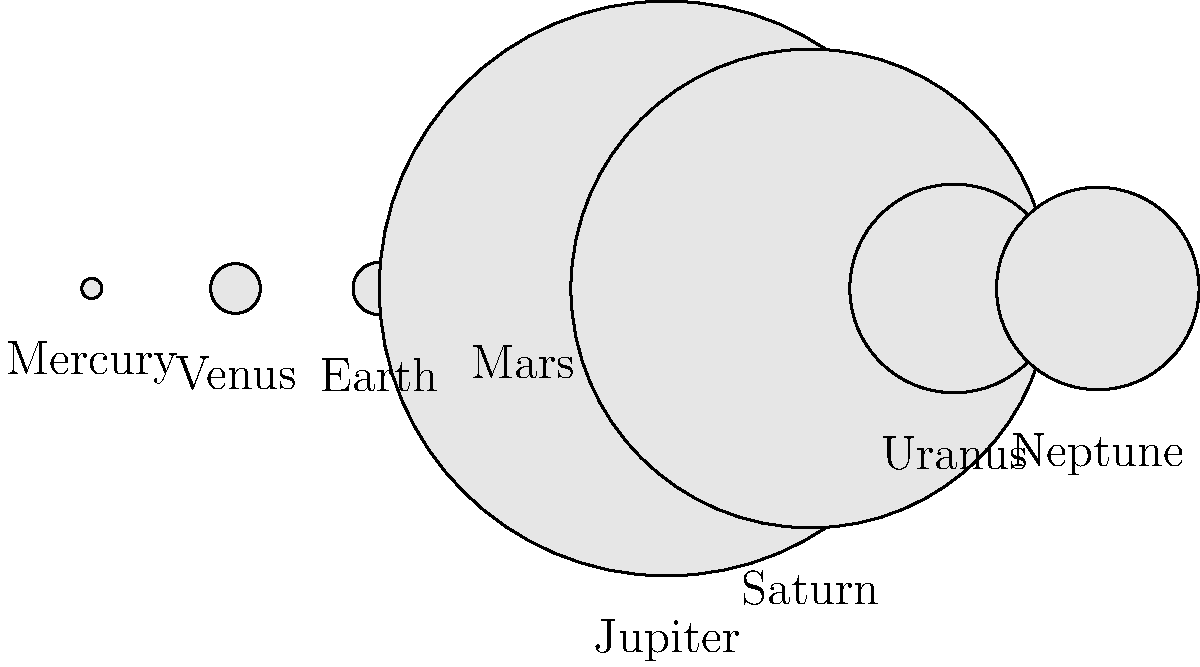In the image above, the planets of our solar system are represented by scaled circles. Given that the Philippine Space Agency (PhilSA) is currently developing educational programs about space science, which planet's representation appears to be significantly larger than the others, and how does this relate to its actual size compared to Earth? To answer this question, let's follow these steps:

1. Observe the image: The circles represent the relative sizes of the planets in our solar system.

2. Identify the largest circle: It's clear that the fifth circle from the left is significantly larger than the others.

3. Match the label: The largest circle is labeled "Jupiter".

4. Compare to Earth: Earth is represented by the third circle from the left.

5. Relative size calculation:
   - Jupiter's diameter: 139,820 km
   - Earth's diameter: 12,742 km
   - Ratio: $\frac{139,820}{12,742} \approx 10.97$

6. Interpretation: Jupiter is about 11 times larger in diameter than Earth.

7. Volume comparison: Since volume scales with the cube of the radius, Jupiter's volume is approximately $11^3 \approx 1,331$ times greater than Earth's.

This significant size difference is accurately represented in the scaled circles, where Jupiter's circle appears much larger than Earth's and the other planets.

Understanding these relative sizes is crucial for PhilSA's educational programs, as it helps to convey the vast scale differences in our solar system and provides context for space exploration and research initiatives.
Answer: Jupiter; approximately 11 times larger in diameter and 1,331 times larger in volume than Earth. 